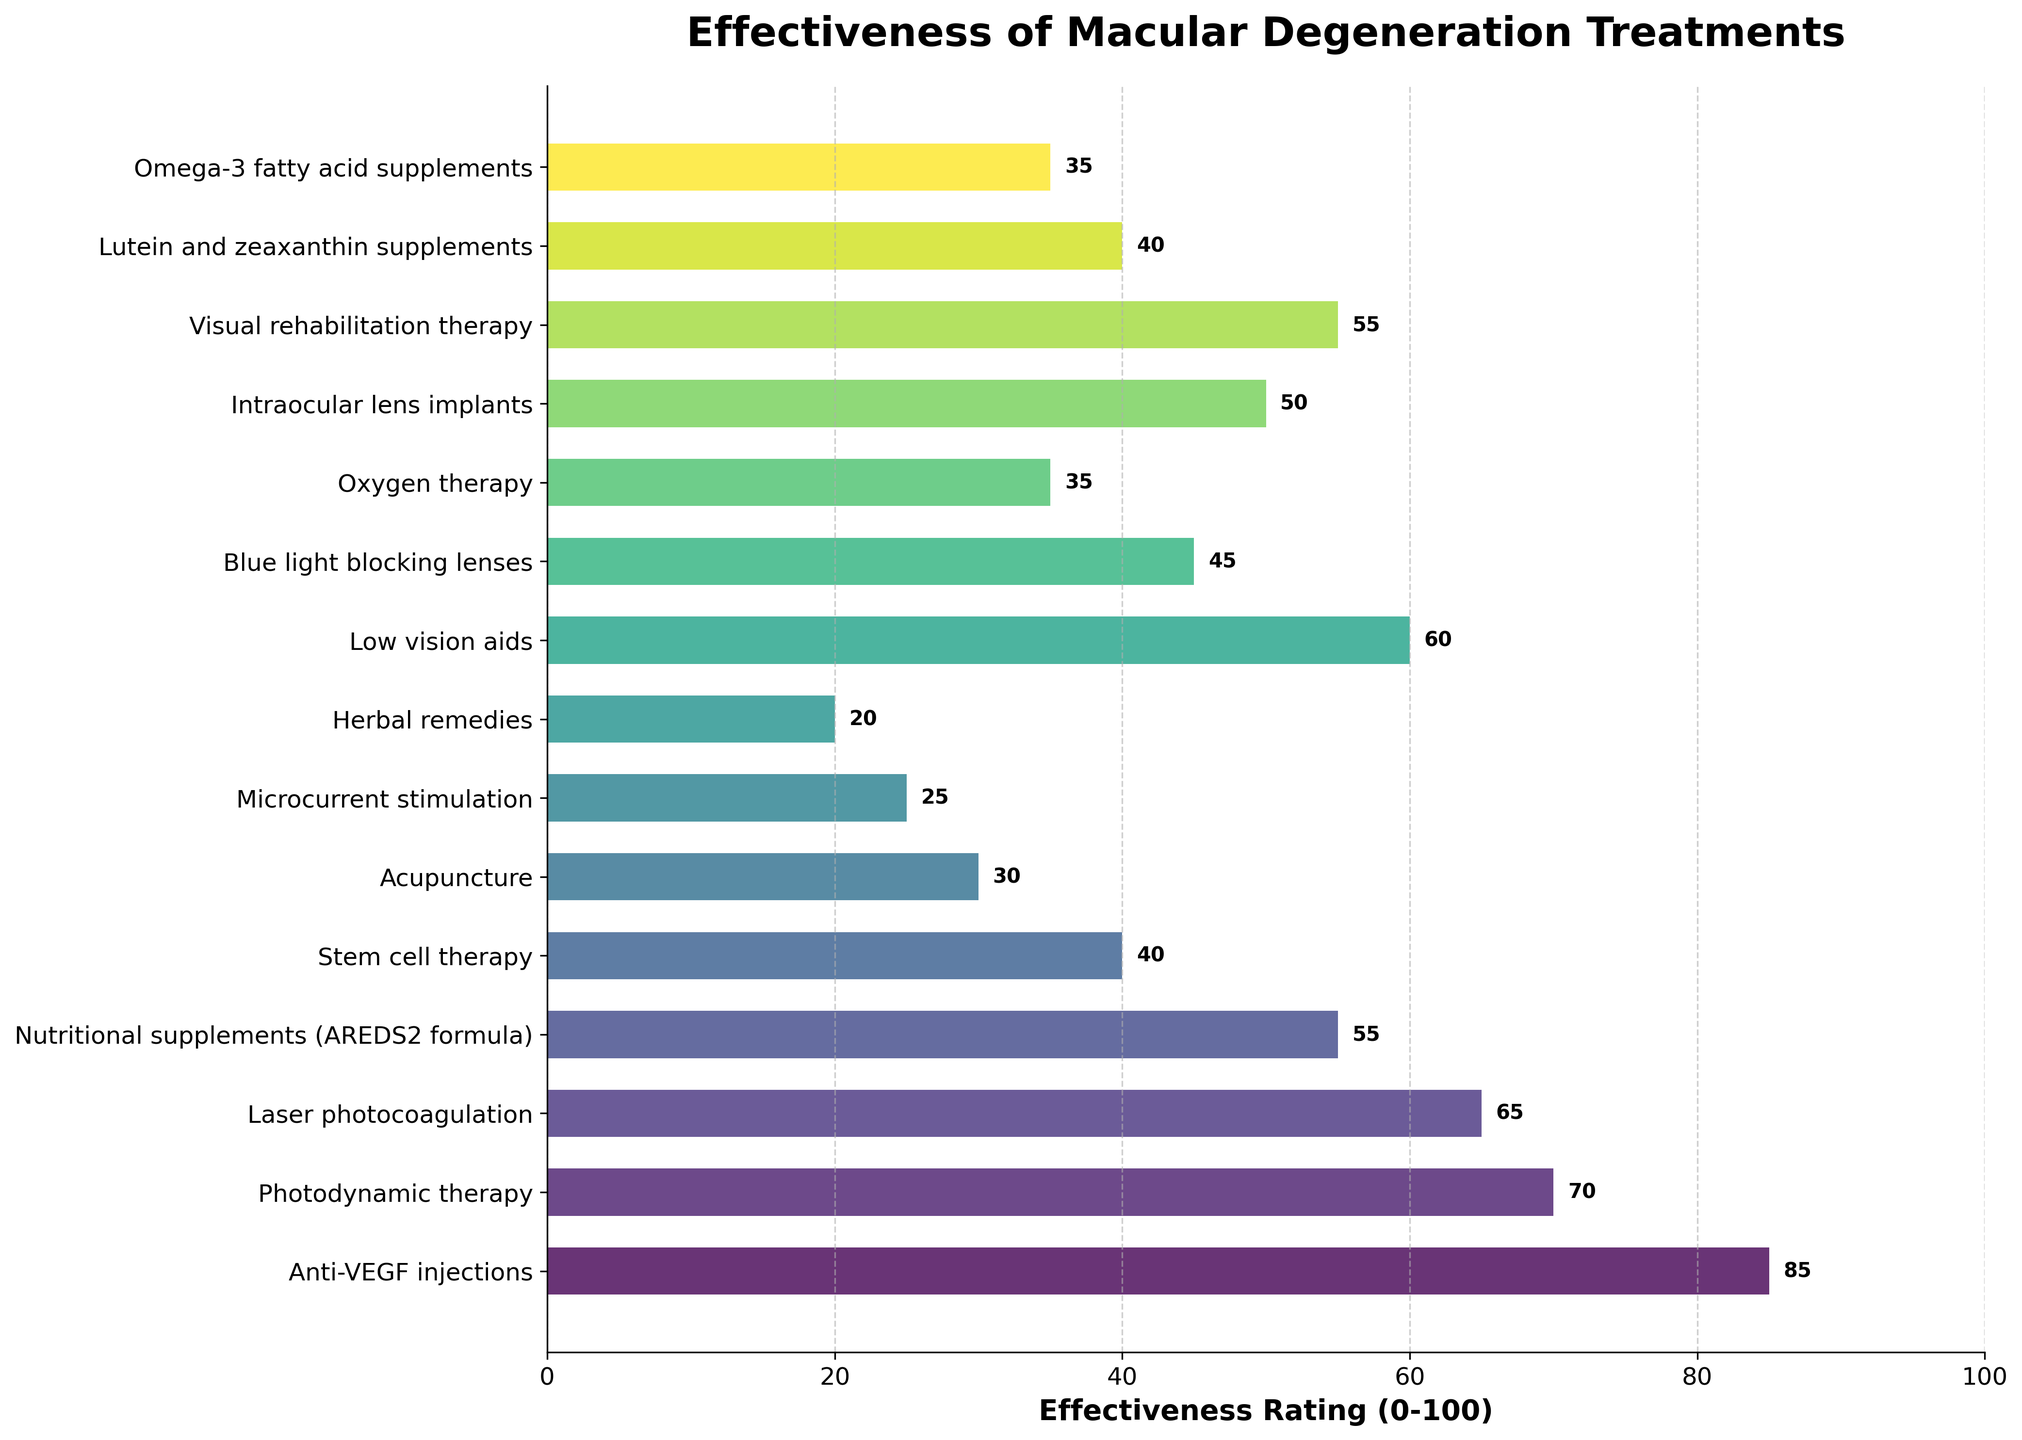what is the effectiveness rating for anti-VEGF injections? Look at the effectiveness rating bar for anti-VEGF injections. The bar is labeled with an effectiveness rating of 85.
Answer: 85 Which treatment has the lowest effectiveness rating? Compare the lengths of all the bars and find the one that is the shortest. Herbal remedies have the shortest bar, indicating the lowest effectiveness rating of 20.
Answer: Herbal remedies What’s the difference in effectiveness rating between anti-VEGF injections and acupuncture? Find the effectiveness ratings for both treatments. Anti-VEGF injections have a rating of 85, and acupuncture has a rating of 30. Subtract the smaller rating from the larger one: 85 - 30 = 55.
Answer: 55 Which treatments have an effectiveness rating above 60? Identify all treatments with bars extending beyond the 60 mark on the x-axis. The treatments are Anti-VEGF injections (85) and Photodynamic therapy (70).
Answer: Anti-VEGF injections, Photodynamic therapy What is the average effectiveness rating of Laser photocoagulation, Visual rehabilitation therapy, and Low vision aids? Find the effectiveness ratings of the three treatments: Laser photocoagulation (65), Visual rehabilitation therapy (55), and Low vision aids (60). Sum these ratings: 65 + 55 + 60 = 180, then divide the sum by 3: 180 / 3 = 60.
Answer: 60 How many treatments have an effectiveness rating below 50? Count the number of bars with values extending below the 50 mark on the x-axis. The treatments are Stem cell therapy (40), Acupuncture (30), Microcurrent stimulation (25), Herbal remedies (20), Blue light blocking lenses (45), Oxygen therapy (35), Lutein and zeaxanthin supplements (40), and Omega-3 fatty acid supplements (35). There are 8 such treatments.
Answer: 8 Which treatment with alternative medicine has the highest effectiveness rating? Identify the treatments that are alternative medicines and compare their effectiveness ratings. Acupuncture (30), Microcurrent stimulation (25), Herbal remedies (20), Blue light blocking lenses (45), Oxygen therapy (35), and Omega-3 fatty acid supplements (35). Blue light blocking lenses have the highest rating of 45.
Answer: Blue light blocking lenses What’s the total effectiveness rating for Nutritional supplements (AREDS2 formula) and Lutein and zeaxanthin supplements? Find the ratings for these treatments: Nutritional supplements (AREDS2 formula) is 55, and Lutein and zeaxanthin supplements is 40. Sum these ratings: 55 + 40 = 95.
Answer: 95 Are there any treatments with the same effectiveness ratings? Compare the effectiveness ratings of each treatment. Nutritional supplements (AREDS2 formula) and Visual rehabilitation therapy both have an effectiveness rating of 55.
Answer: Yes, Nutritional supplements (AREDS2 formula) and Visual rehabilitation therapy 